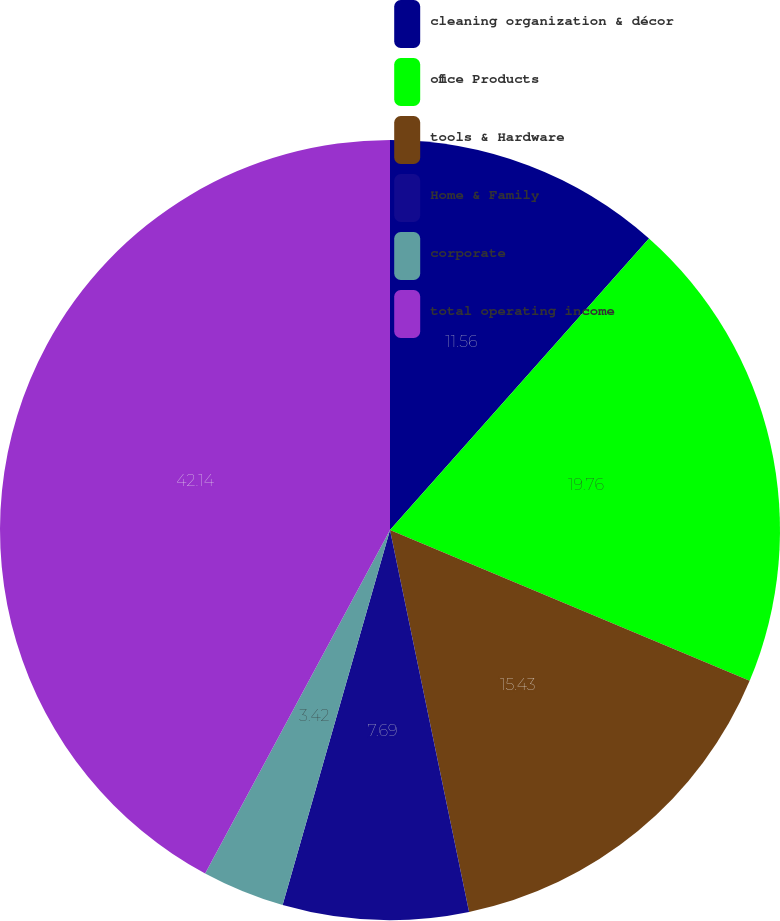<chart> <loc_0><loc_0><loc_500><loc_500><pie_chart><fcel>cleaning organization & décor<fcel>office Products<fcel>tools & Hardware<fcel>Home & Family<fcel>corporate<fcel>total operating income<nl><fcel>11.56%<fcel>19.76%<fcel>15.43%<fcel>7.69%<fcel>3.42%<fcel>42.14%<nl></chart> 